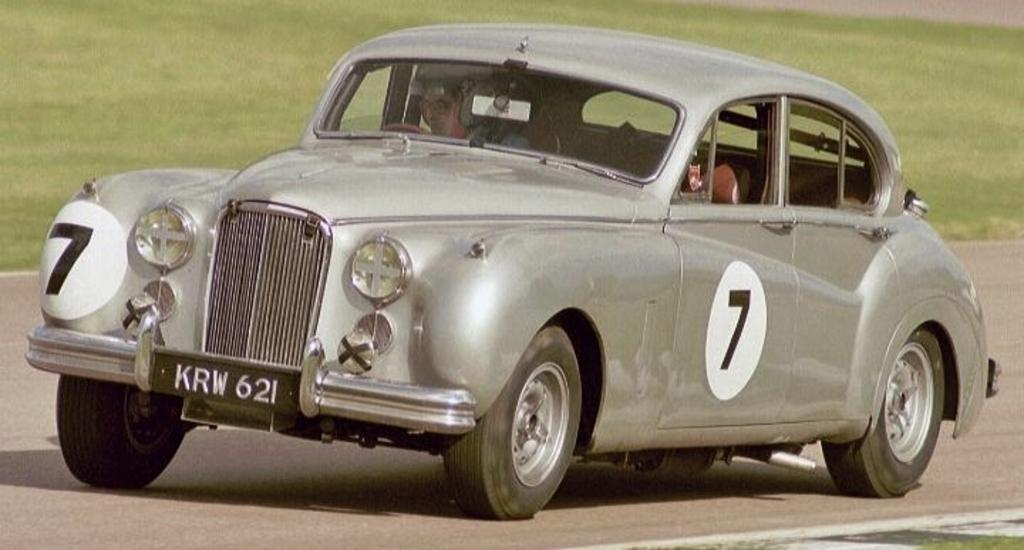What is the main subject of the image? The main subject of the image is a person inside a car. Can you describe the background of the image? The background of the image is blurred. What type of poison is the person in the car using in the image? There is no indication in the image that the person in the car is using any type of poison. What type of train can be seen passing by in the image? There is no train present in the image. 